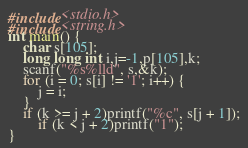Convert code to text. <code><loc_0><loc_0><loc_500><loc_500><_C_>#include<stdio.h>
#include<string.h>
int main() {
	char s[105];
	long long int i,j=-1,p[105],k;
	scanf("%s%lld", s,&k);
	for (i = 0; s[i] != '1'; i++) {
		j = i;
	}
	if (k >= j + 2)printf("%c", s[j + 1]);
		if (k < j + 2)printf("1");
}</code> 